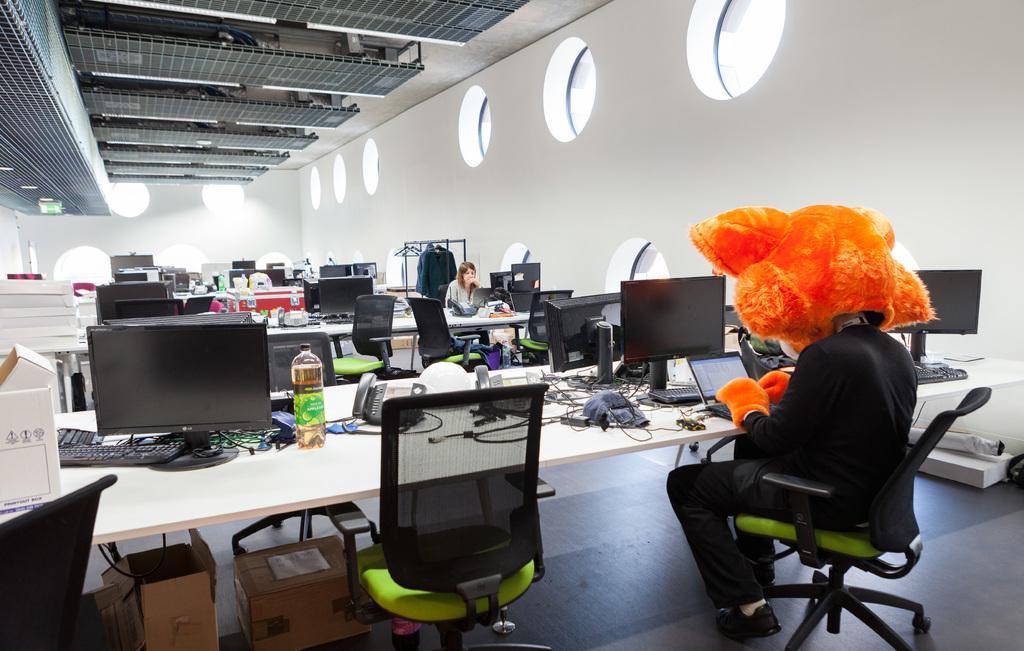Please provide a concise description of this image. In this image I can see there are two people who are sitting on a chair in front of a table. I can see there are few empty chairs on the floor and a couple of tables. On the table we have a bottle, telephones and few other objects on it. 